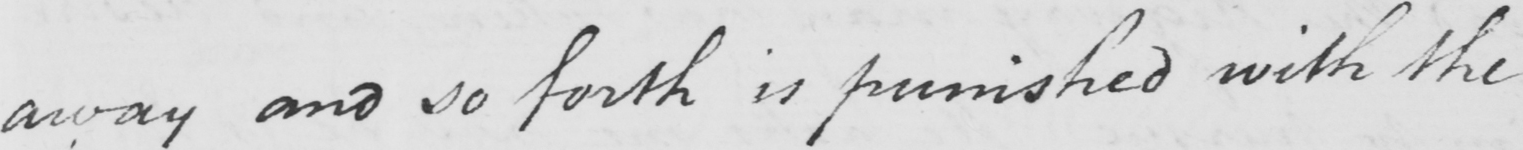What text is written in this handwritten line? away and so forth is punished with the 